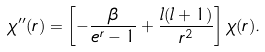<formula> <loc_0><loc_0><loc_500><loc_500>\chi ^ { \prime \prime } ( r ) = \left [ - \frac { \beta } { e ^ { r } - 1 } + \frac { l ( l + 1 ) } { r ^ { 2 } } \right ] \chi ( r ) .</formula> 